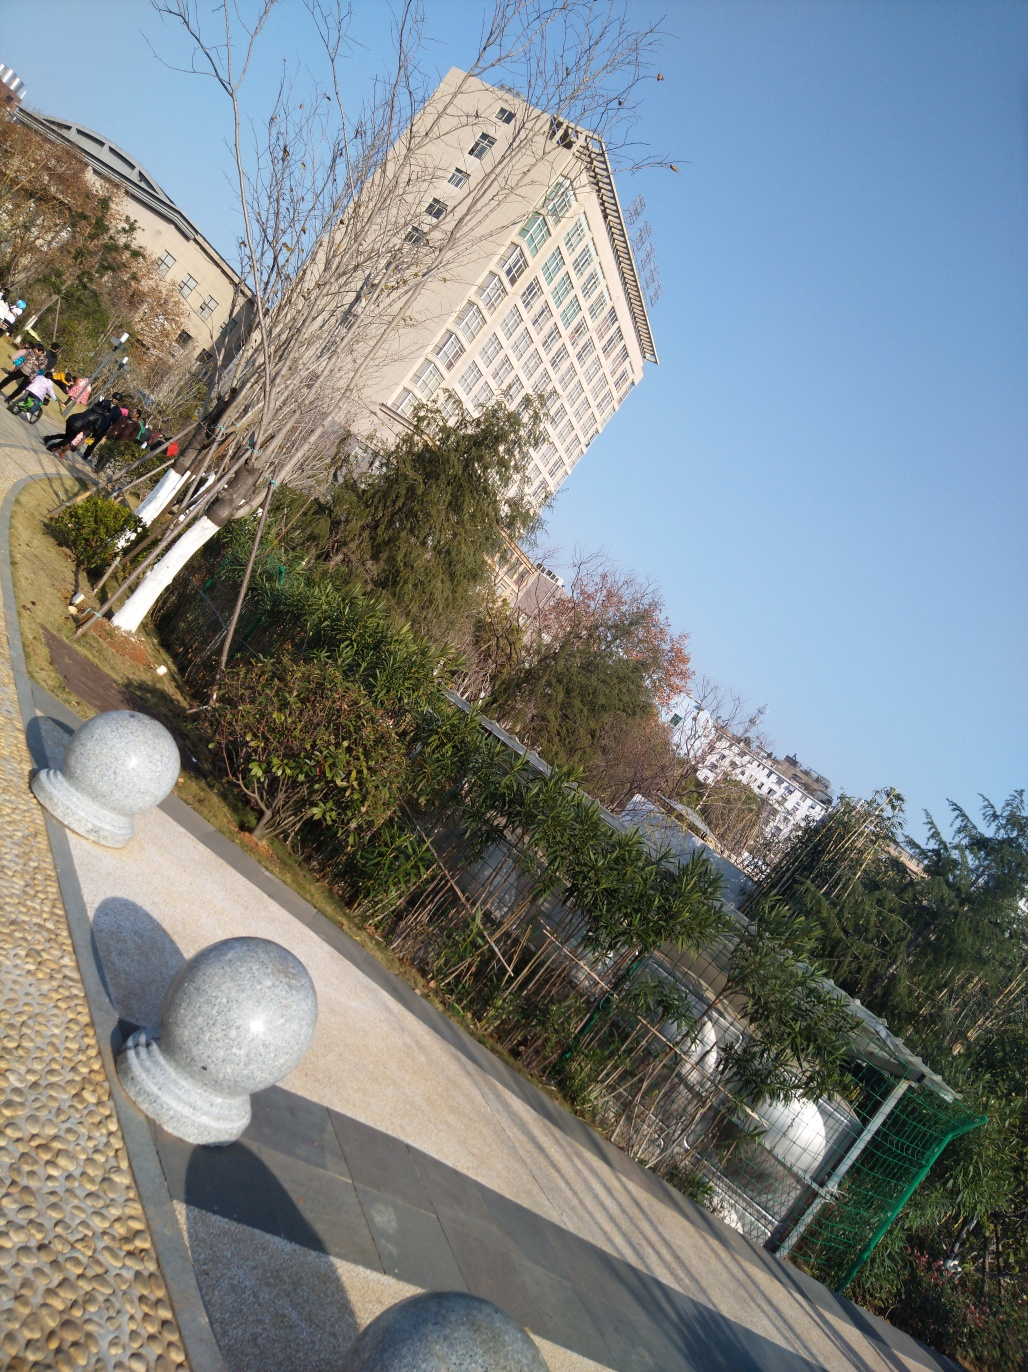Are there any quality issues with this image? Yes, there are a few quality issues with the image. It appears to be taken at a skewed angle, which makes the building look tilted. This perspective can create an unnatural and disorienting view. Additionally, the image seems overexposed on the right side, leading to a loss of detail in the brighter areas. Correcting the angle and adjusting the exposure could significantly improve the visual quality. 